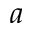Convert formula to latex. <formula><loc_0><loc_0><loc_500><loc_500>a</formula> 